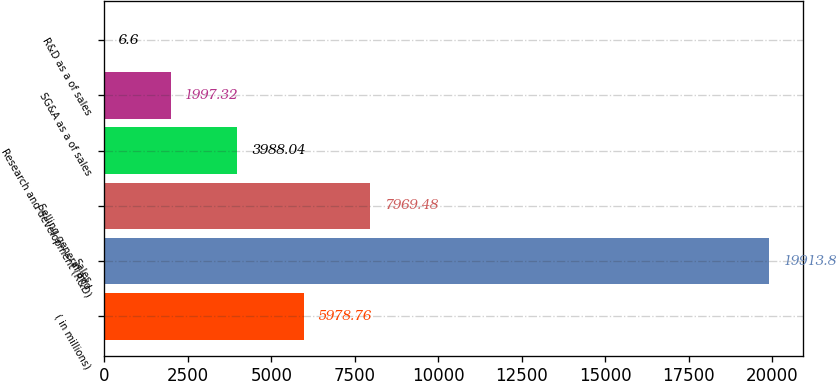<chart> <loc_0><loc_0><loc_500><loc_500><bar_chart><fcel>( in millions)<fcel>Sales<fcel>Selling general and<fcel>Research and development (R&D)<fcel>SG&A as a of sales<fcel>R&D as a of sales<nl><fcel>5978.76<fcel>19913.8<fcel>7969.48<fcel>3988.04<fcel>1997.32<fcel>6.6<nl></chart> 